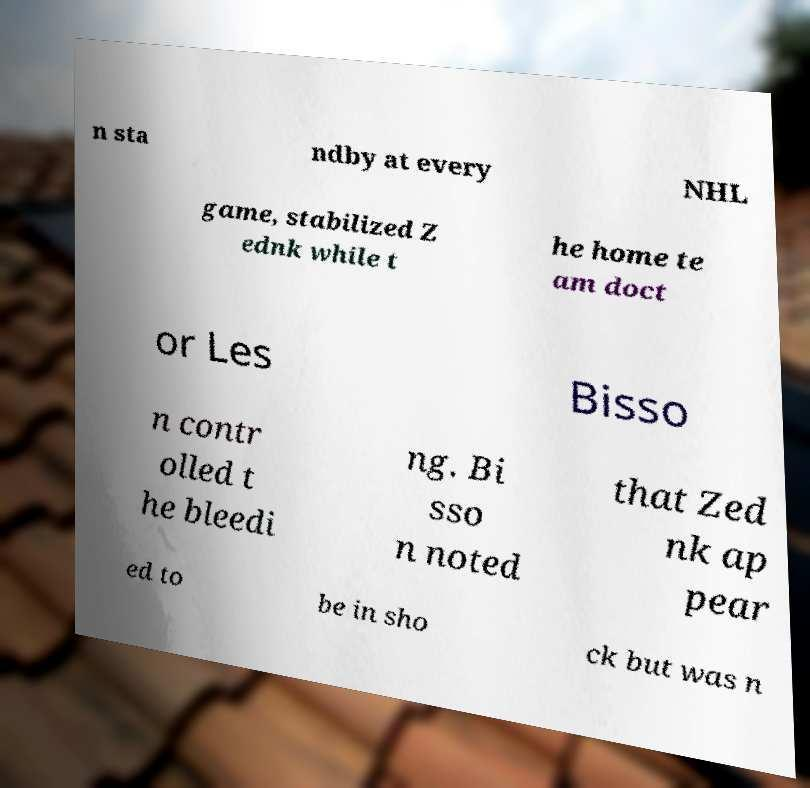Could you assist in decoding the text presented in this image and type it out clearly? n sta ndby at every NHL game, stabilized Z ednk while t he home te am doct or Les Bisso n contr olled t he bleedi ng. Bi sso n noted that Zed nk ap pear ed to be in sho ck but was n 